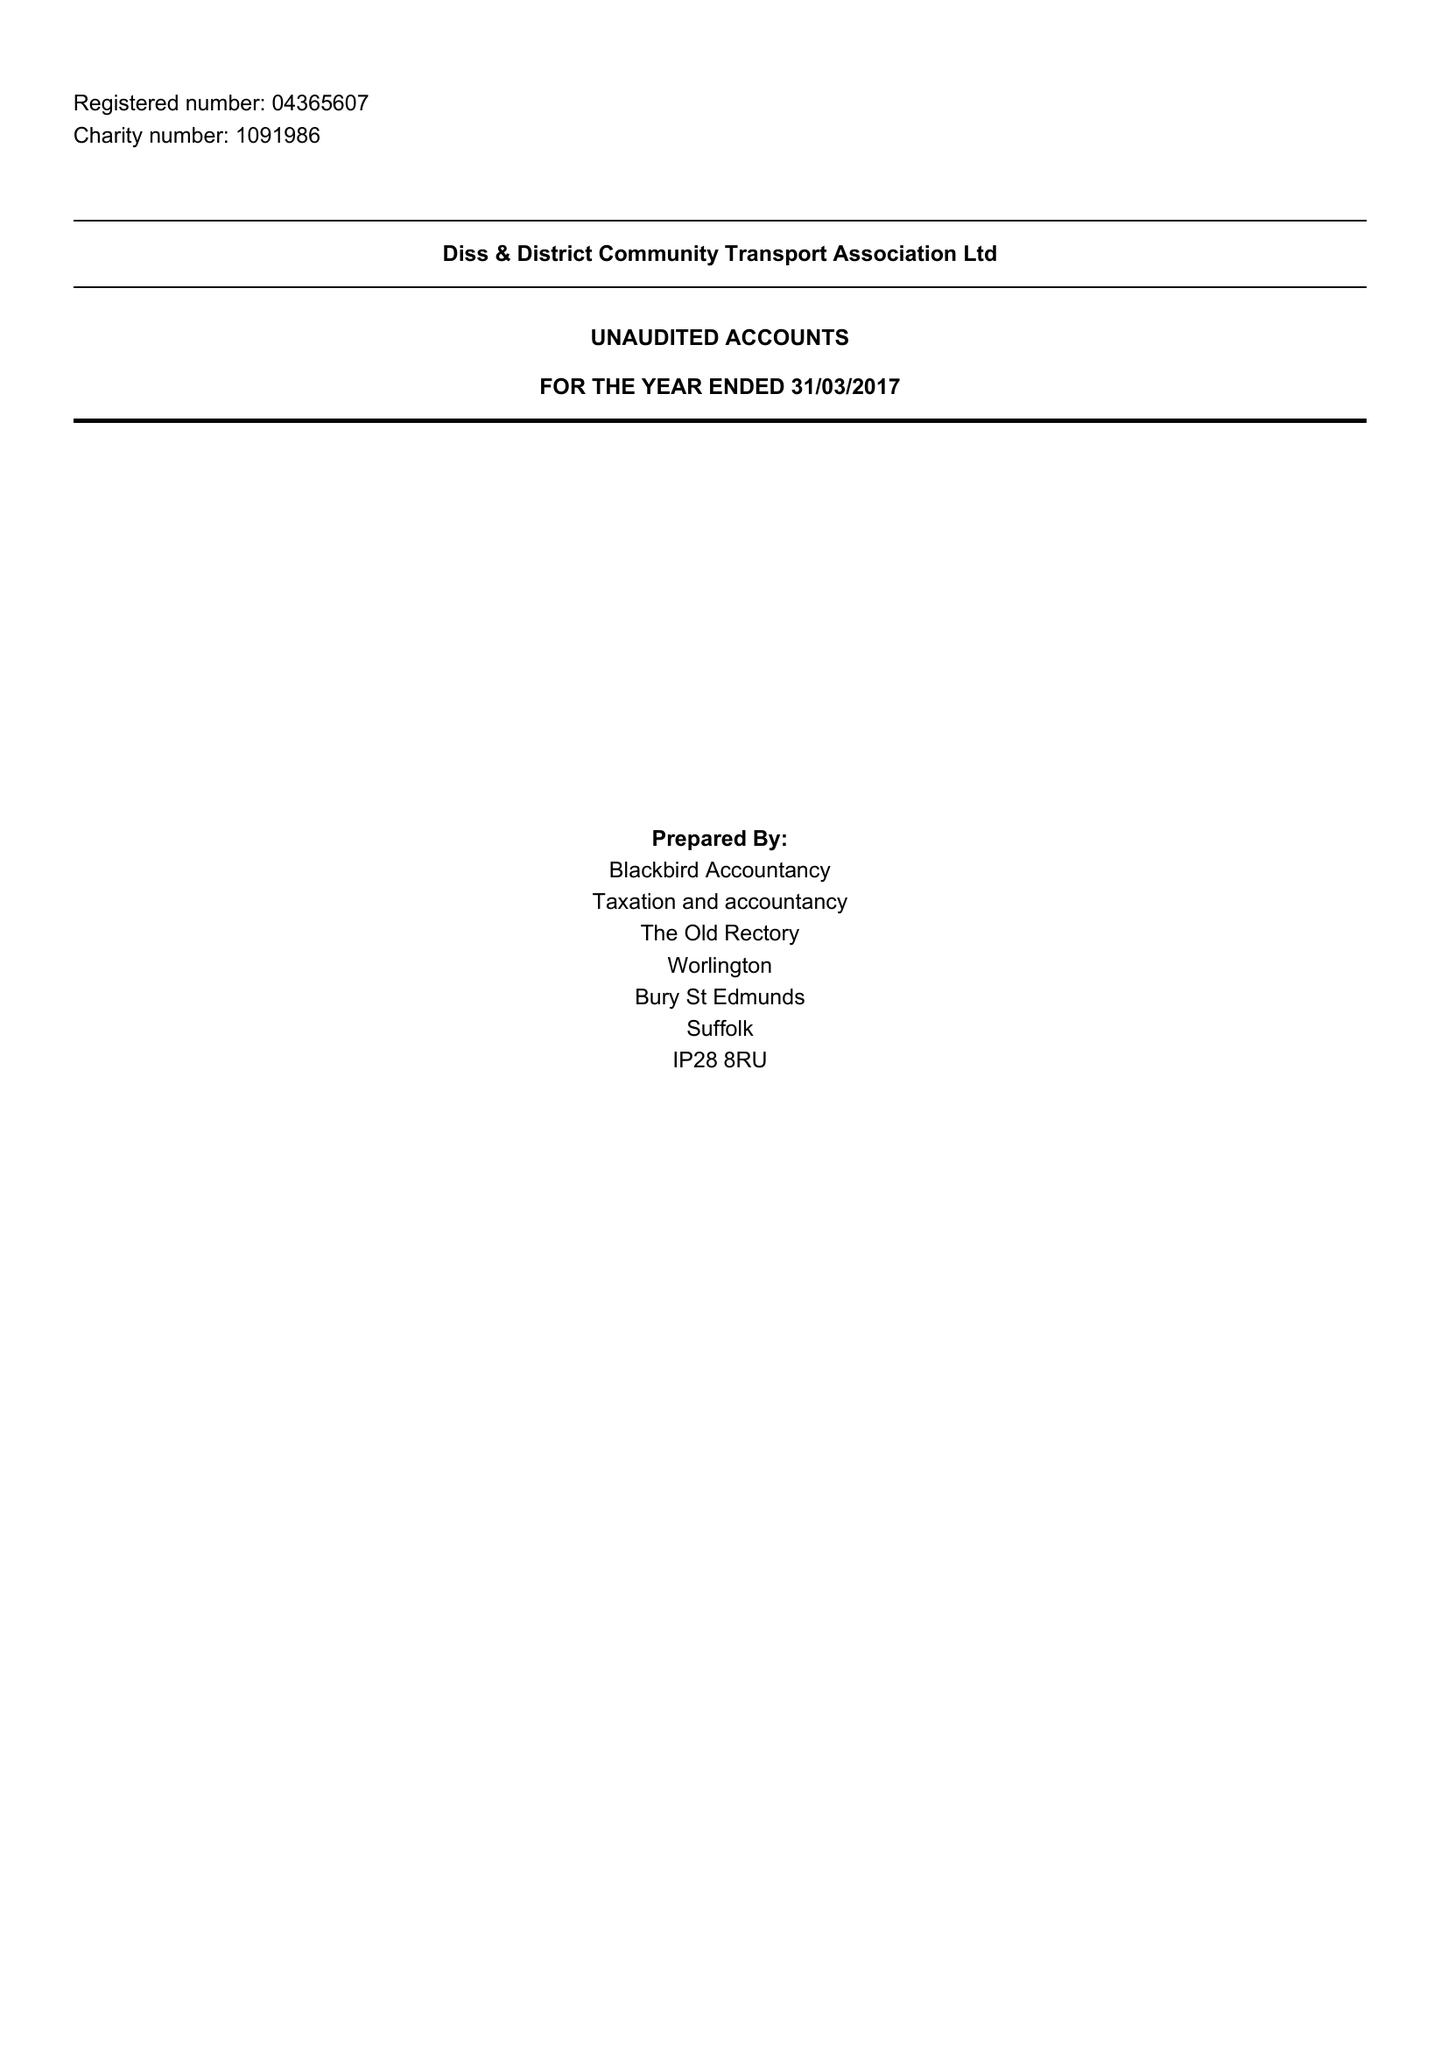What is the value for the spending_annually_in_british_pounds?
Answer the question using a single word or phrase. 186874.00 